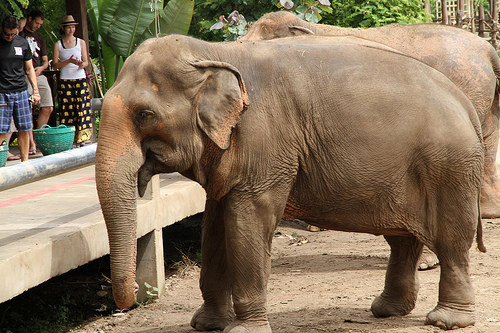Is the floor in front of a monkey? No, the floor is in front of an elephant, not a monkey. 